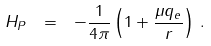Convert formula to latex. <formula><loc_0><loc_0><loc_500><loc_500>H _ { P } \ = \ - \frac { 1 } { 4 \pi } \left ( 1 + \frac { \mu q _ { e } } { r } \right ) \, .</formula> 